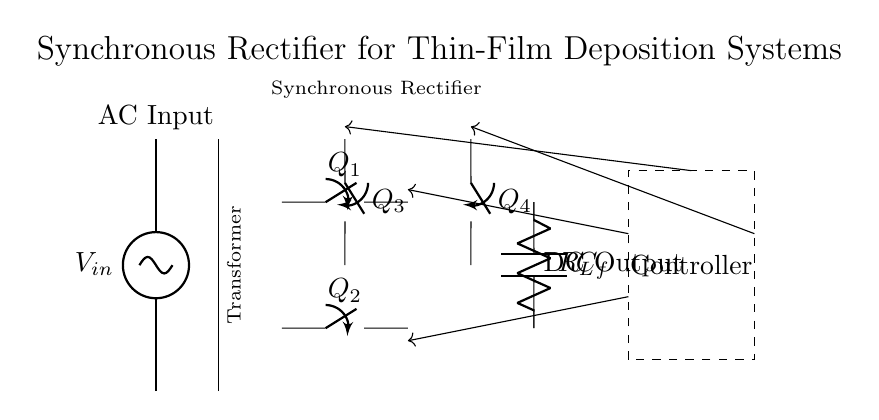What is the type of input voltage in this circuit? The input voltage is from an AC source, as indicated by the labeled AC Input in the circuit.
Answer: AC What are the components labeled as Q1 and Q2? Q1 and Q2 are both labeled as synchronous rectifiers, which are switching devices used for converting AC to DC in the circuit.
Answer: Synchronous rectifiers How many capacitors are present in the circuit? There is one capacitor present, labeled as C_f, which is used for smoothing the output DC voltage.
Answer: One What does the dashed rectangle represent in the circuit? The dashed rectangle represents the Controller, which likely manages the operation of the synchronous rectifiers to optimize efficiency.
Answer: Controller Which components are responsible for reducing power loss during rectification? The synchronous rectifiers, represented by Q1, Q2, Q3, and Q4, are specifically designed to reduce power loss compared to traditional diode rectifiers.
Answer: Synchronous rectifiers What is the role of the transformer in this circuit? The transformer isolates and steps down the AC voltage to a suitable level for rectification before it reaches the synchronous rectifiers.
Answer: Isolation and stepping down voltage What is the output of this circuit? The output of the circuit is a DC voltage that is provided across the load resistor R_L and capacitor C_f, as denoted by the labeled DC Output.
Answer: DC Output 